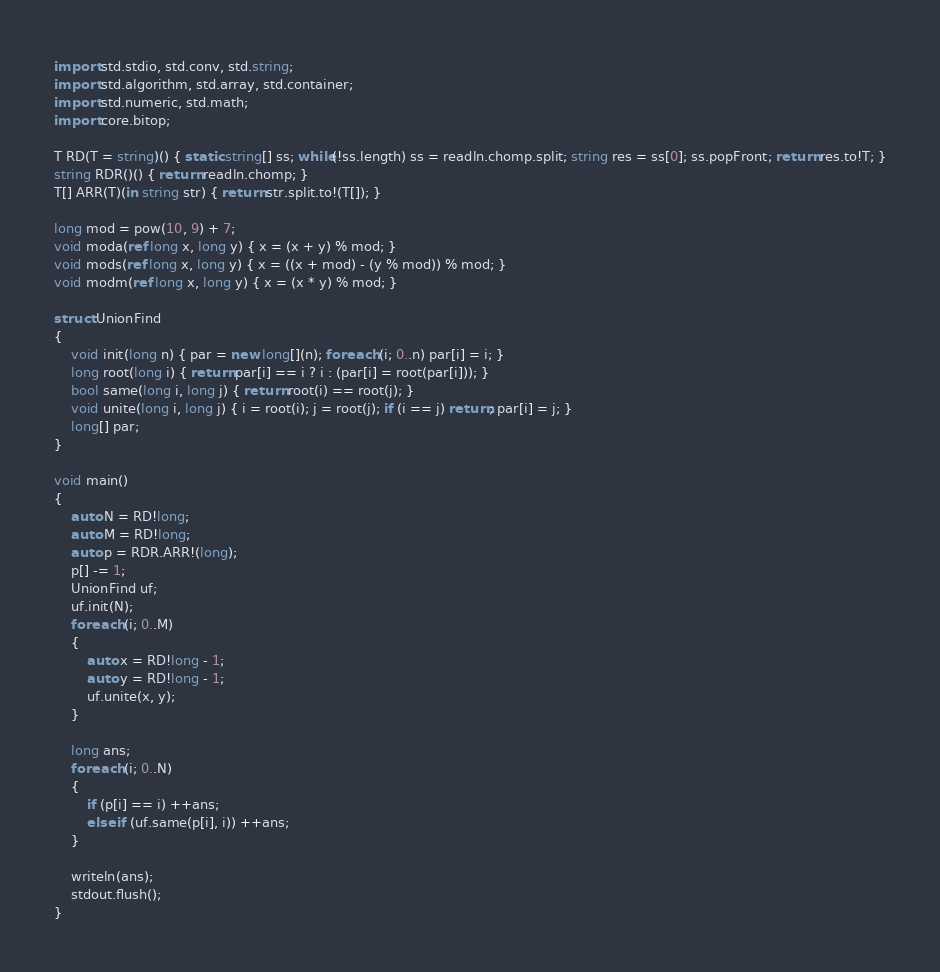<code> <loc_0><loc_0><loc_500><loc_500><_D_>import std.stdio, std.conv, std.string;
import std.algorithm, std.array, std.container;
import std.numeric, std.math;
import core.bitop;

T RD(T = string)() { static string[] ss; while(!ss.length) ss = readln.chomp.split; string res = ss[0]; ss.popFront; return res.to!T; }
string RDR()() { return readln.chomp; }
T[] ARR(T)(in string str) { return str.split.to!(T[]); }

long mod = pow(10, 9) + 7;
void moda(ref long x, long y) { x = (x + y) % mod; }
void mods(ref long x, long y) { x = ((x + mod) - (y % mod)) % mod; }
void modm(ref long x, long y) { x = (x * y) % mod; }

struct UnionFind
{
	void init(long n) { par = new long[](n); foreach (i; 0..n) par[i] = i; }
	long root(long i) { return par[i] == i ? i : (par[i] = root(par[i])); }
	bool same(long i, long j) { return root(i) == root(j); }
	void unite(long i, long j) { i = root(i); j = root(j); if (i == j) return; par[i] = j; }
	long[] par;
}

void main()
{
	auto N = RD!long;
	auto M = RD!long;
	auto p = RDR.ARR!(long);
	p[] -= 1;
	UnionFind uf;
	uf.init(N);
	foreach (i; 0..M)
	{
		auto x = RD!long - 1;
		auto y = RD!long - 1;
		uf.unite(x, y);
	}

	long ans;
	foreach (i; 0..N)
	{
		if (p[i] == i) ++ans;
		else if (uf.same(p[i], i)) ++ans;
	}

	writeln(ans);
	stdout.flush();
}</code> 